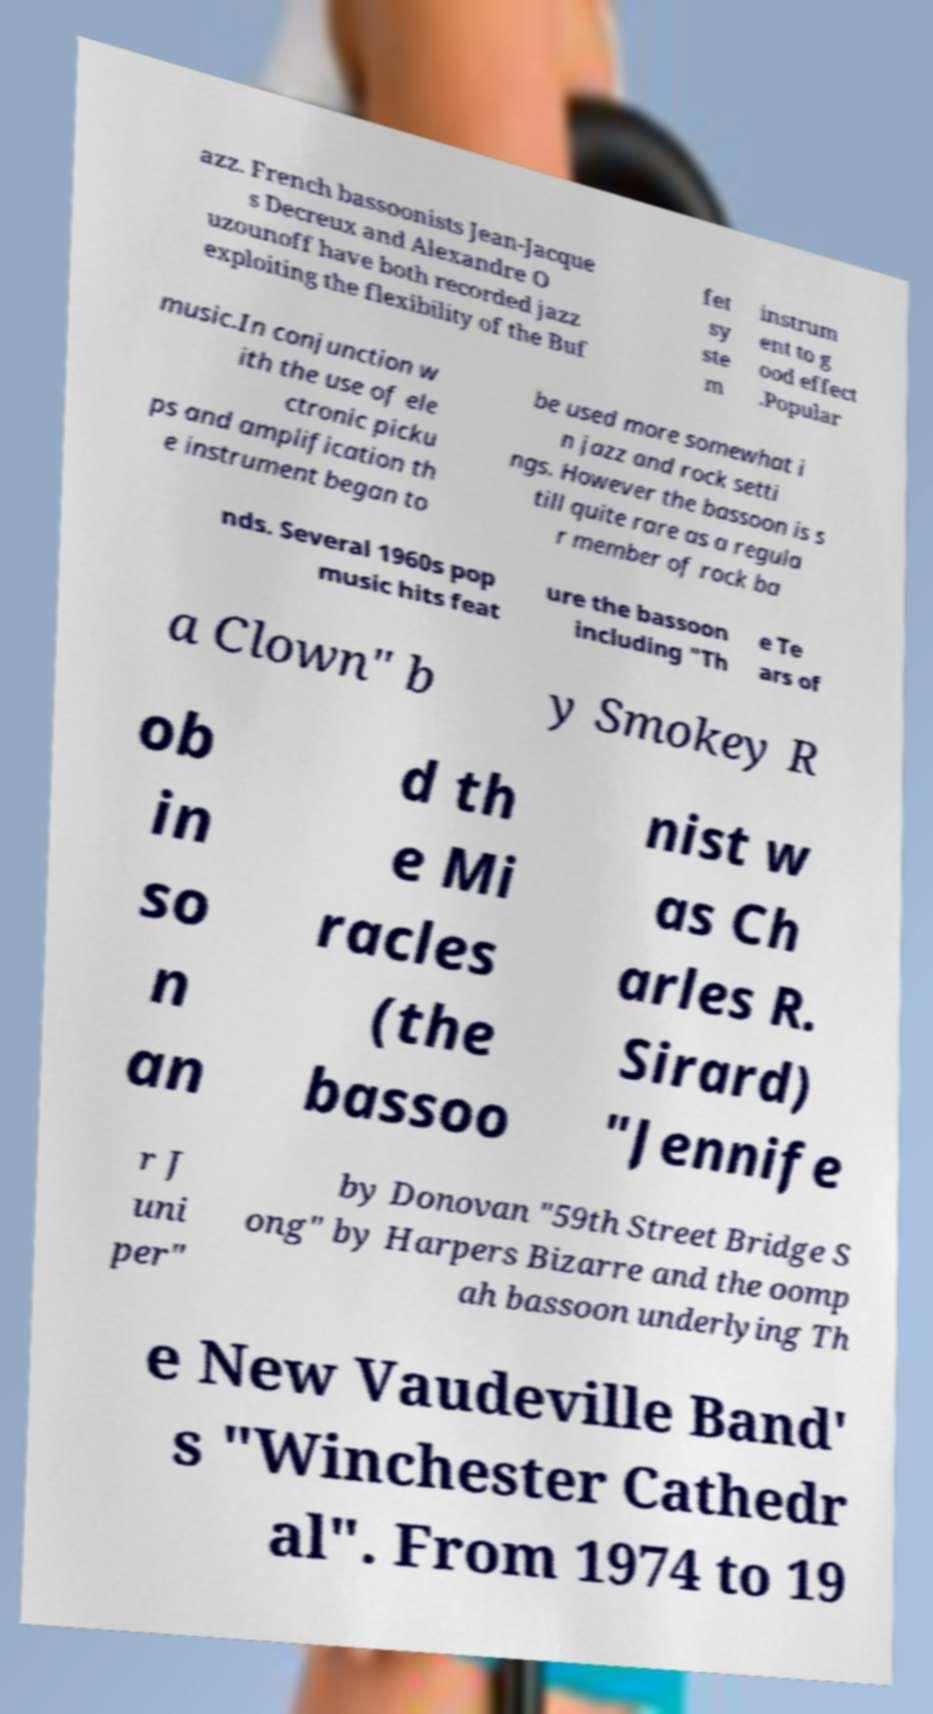What makes the Buffet bassoon system preferable for jazz and popular music contexts? The Buffet system bassoon is highly regarded for its flexibility in sound production and its ability to adapt to various musical styles. This system offers a richer, more resonant tone that can blend well with other instruments typically used in jazz and pop. Its technical design allows for smoother fingering techniques, making it easier for musicians to perform complex jazz improvisations and extended techniques required in these genres. 